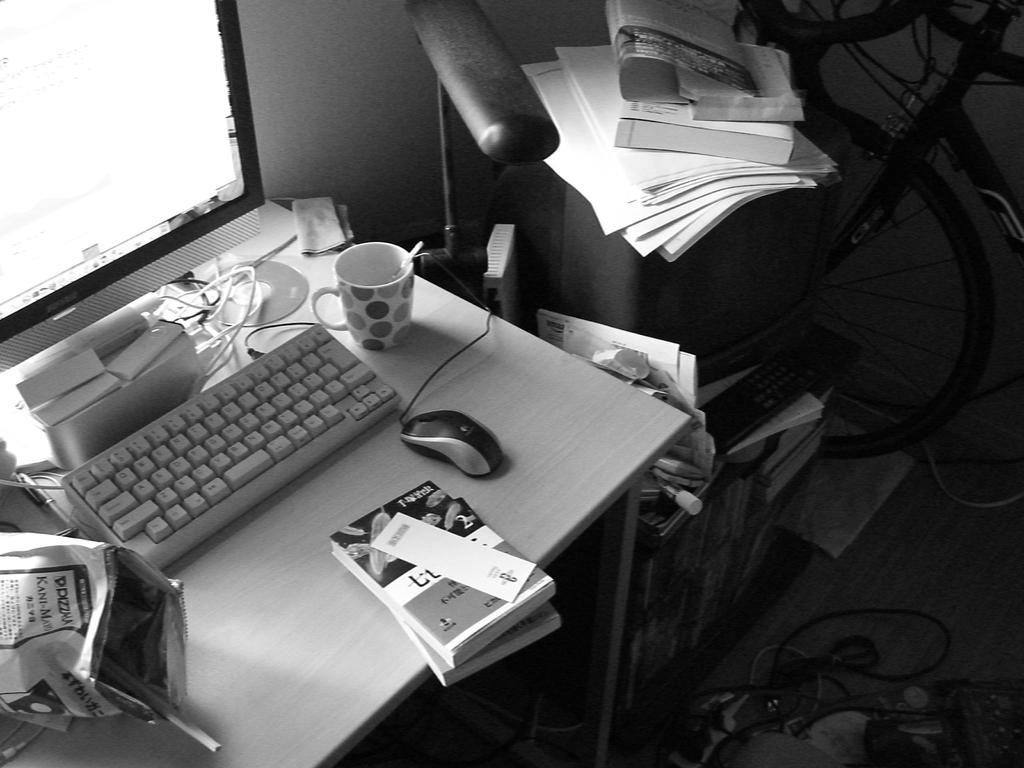Could you give a brief overview of what you see in this image? In the image there is a table. On table we can see two books,cover,mouse,cpu,keyboard,monitor. On right side there is a cycle,television,remote,papers,books which are placed on table. In background there is a wall which is in white color. 